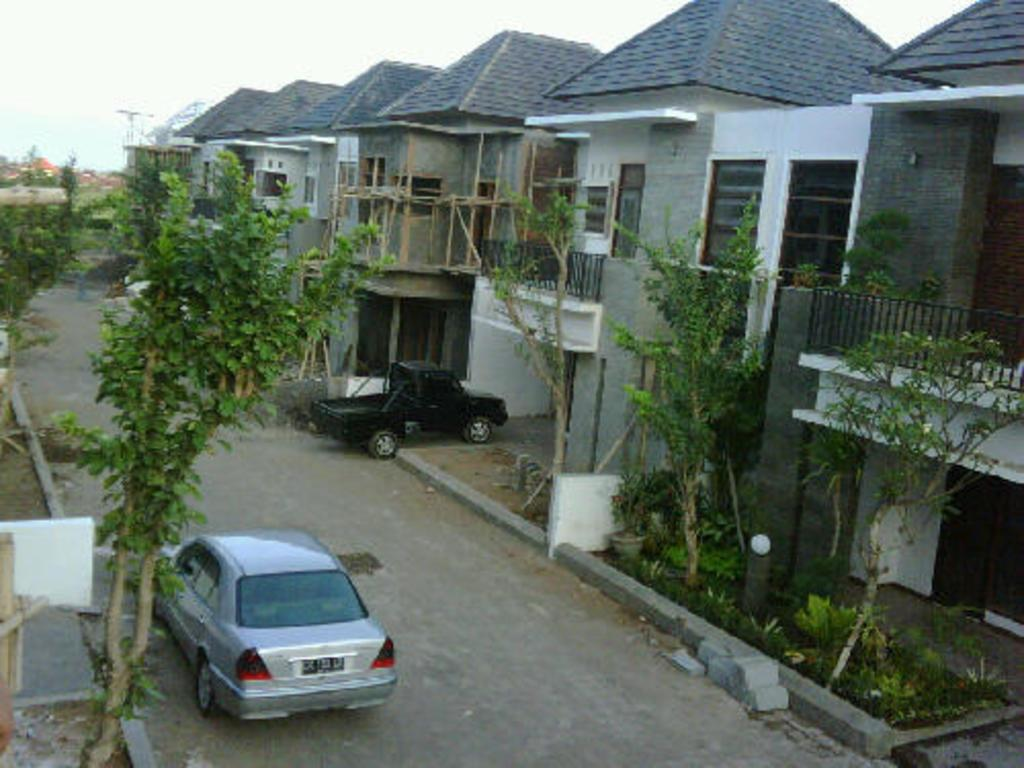What type of structures can be seen in the image? There are houses in the image. What type of vegetation is present in the image? There are trees in the image. What type of vehicles can be seen on the road in the image? There are cars on the road in the image. What is visible at the top of the image? The sky is visible at the top of the image. What type of spoon is being used to mix the poison in the image? There is no spoon or poison present in the image. How is the division between the houses and trees being maintained in the image? There is no division being maintained in the image; it is a static representation of houses, trees, cars, and the sky. 